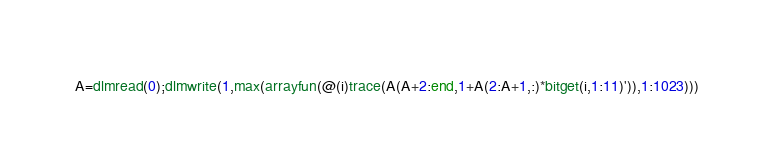<code> <loc_0><loc_0><loc_500><loc_500><_Octave_>A=dlmread(0);dlmwrite(1,max(arrayfun(@(i)trace(A(A+2:end,1+A(2:A+1,:)*bitget(i,1:11)')),1:1023)))</code> 